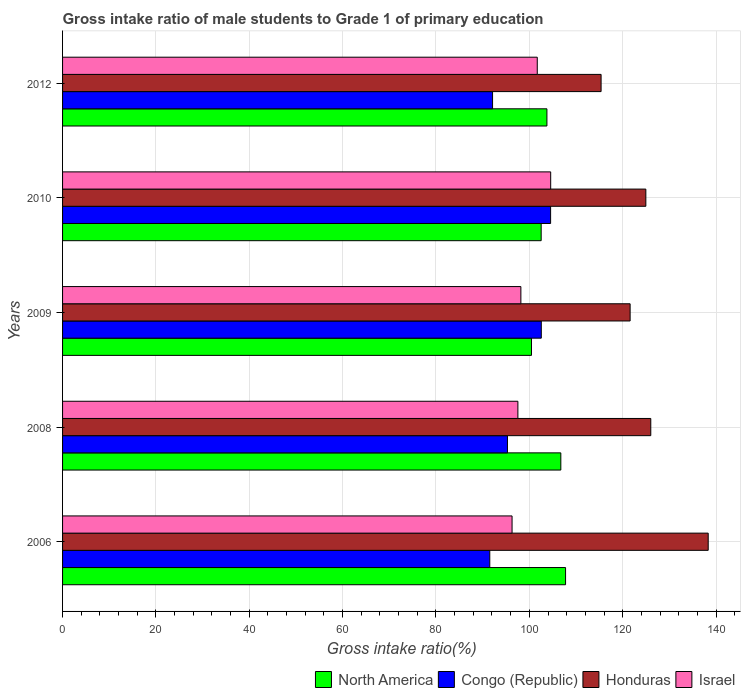Are the number of bars on each tick of the Y-axis equal?
Your answer should be very brief. Yes. How many bars are there on the 1st tick from the top?
Your answer should be compact. 4. How many bars are there on the 1st tick from the bottom?
Offer a very short reply. 4. In how many cases, is the number of bars for a given year not equal to the number of legend labels?
Offer a very short reply. 0. What is the gross intake ratio in North America in 2010?
Provide a short and direct response. 102.54. Across all years, what is the maximum gross intake ratio in North America?
Your answer should be compact. 107.76. Across all years, what is the minimum gross intake ratio in North America?
Provide a succinct answer. 100.46. In which year was the gross intake ratio in North America maximum?
Provide a succinct answer. 2006. What is the total gross intake ratio in Congo (Republic) in the graph?
Provide a succinct answer. 486.09. What is the difference between the gross intake ratio in Israel in 2008 and that in 2009?
Give a very brief answer. -0.64. What is the difference between the gross intake ratio in Congo (Republic) in 2009 and the gross intake ratio in Israel in 2012?
Ensure brevity in your answer.  0.86. What is the average gross intake ratio in Honduras per year?
Your response must be concise. 125.25. In the year 2010, what is the difference between the gross intake ratio in North America and gross intake ratio in Honduras?
Provide a short and direct response. -22.42. What is the ratio of the gross intake ratio in Israel in 2006 to that in 2010?
Give a very brief answer. 0.92. Is the gross intake ratio in Israel in 2006 less than that in 2009?
Provide a short and direct response. Yes. Is the difference between the gross intake ratio in North America in 2008 and 2012 greater than the difference between the gross intake ratio in Honduras in 2008 and 2012?
Your response must be concise. No. What is the difference between the highest and the second highest gross intake ratio in North America?
Make the answer very short. 1.01. What is the difference between the highest and the lowest gross intake ratio in Honduras?
Provide a succinct answer. 22.95. Is it the case that in every year, the sum of the gross intake ratio in Israel and gross intake ratio in Honduras is greater than the sum of gross intake ratio in North America and gross intake ratio in Congo (Republic)?
Offer a terse response. No. What does the 4th bar from the top in 2006 represents?
Give a very brief answer. North America. What does the 2nd bar from the bottom in 2010 represents?
Ensure brevity in your answer.  Congo (Republic). Is it the case that in every year, the sum of the gross intake ratio in Congo (Republic) and gross intake ratio in Israel is greater than the gross intake ratio in North America?
Provide a short and direct response. Yes. How many bars are there?
Keep it short and to the point. 20. Are all the bars in the graph horizontal?
Provide a short and direct response. Yes. How many years are there in the graph?
Your answer should be very brief. 5. Are the values on the major ticks of X-axis written in scientific E-notation?
Offer a terse response. No. Does the graph contain grids?
Keep it short and to the point. Yes. How are the legend labels stacked?
Offer a terse response. Horizontal. What is the title of the graph?
Give a very brief answer. Gross intake ratio of male students to Grade 1 of primary education. Does "Low income" appear as one of the legend labels in the graph?
Provide a short and direct response. No. What is the label or title of the X-axis?
Your answer should be compact. Gross intake ratio(%). What is the Gross intake ratio(%) of North America in 2006?
Give a very brief answer. 107.76. What is the Gross intake ratio(%) of Congo (Republic) in 2006?
Ensure brevity in your answer.  91.53. What is the Gross intake ratio(%) of Honduras in 2006?
Offer a terse response. 138.32. What is the Gross intake ratio(%) of Israel in 2006?
Provide a succinct answer. 96.3. What is the Gross intake ratio(%) in North America in 2008?
Give a very brief answer. 106.75. What is the Gross intake ratio(%) of Congo (Republic) in 2008?
Make the answer very short. 95.32. What is the Gross intake ratio(%) in Honduras in 2008?
Offer a very short reply. 126.02. What is the Gross intake ratio(%) in Israel in 2008?
Offer a terse response. 97.55. What is the Gross intake ratio(%) in North America in 2009?
Offer a terse response. 100.46. What is the Gross intake ratio(%) of Congo (Republic) in 2009?
Provide a short and direct response. 102.57. What is the Gross intake ratio(%) of Honduras in 2009?
Offer a very short reply. 121.59. What is the Gross intake ratio(%) of Israel in 2009?
Your answer should be compact. 98.19. What is the Gross intake ratio(%) in North America in 2010?
Offer a very short reply. 102.54. What is the Gross intake ratio(%) of Congo (Republic) in 2010?
Your response must be concise. 104.56. What is the Gross intake ratio(%) of Honduras in 2010?
Make the answer very short. 124.96. What is the Gross intake ratio(%) of Israel in 2010?
Provide a short and direct response. 104.58. What is the Gross intake ratio(%) in North America in 2012?
Your answer should be compact. 103.77. What is the Gross intake ratio(%) of Congo (Republic) in 2012?
Give a very brief answer. 92.12. What is the Gross intake ratio(%) of Honduras in 2012?
Provide a succinct answer. 115.37. What is the Gross intake ratio(%) of Israel in 2012?
Offer a terse response. 101.7. Across all years, what is the maximum Gross intake ratio(%) of North America?
Provide a short and direct response. 107.76. Across all years, what is the maximum Gross intake ratio(%) in Congo (Republic)?
Ensure brevity in your answer.  104.56. Across all years, what is the maximum Gross intake ratio(%) of Honduras?
Make the answer very short. 138.32. Across all years, what is the maximum Gross intake ratio(%) of Israel?
Your answer should be very brief. 104.58. Across all years, what is the minimum Gross intake ratio(%) in North America?
Give a very brief answer. 100.46. Across all years, what is the minimum Gross intake ratio(%) in Congo (Republic)?
Ensure brevity in your answer.  91.53. Across all years, what is the minimum Gross intake ratio(%) in Honduras?
Offer a terse response. 115.37. Across all years, what is the minimum Gross intake ratio(%) of Israel?
Offer a terse response. 96.3. What is the total Gross intake ratio(%) of North America in the graph?
Offer a terse response. 521.27. What is the total Gross intake ratio(%) of Congo (Republic) in the graph?
Provide a succinct answer. 486.09. What is the total Gross intake ratio(%) in Honduras in the graph?
Offer a terse response. 626.27. What is the total Gross intake ratio(%) in Israel in the graph?
Offer a terse response. 498.31. What is the difference between the Gross intake ratio(%) in North America in 2006 and that in 2008?
Your answer should be very brief. 1.01. What is the difference between the Gross intake ratio(%) of Congo (Republic) in 2006 and that in 2008?
Your answer should be very brief. -3.79. What is the difference between the Gross intake ratio(%) of Honduras in 2006 and that in 2008?
Keep it short and to the point. 12.31. What is the difference between the Gross intake ratio(%) of Israel in 2006 and that in 2008?
Provide a succinct answer. -1.25. What is the difference between the Gross intake ratio(%) in North America in 2006 and that in 2009?
Ensure brevity in your answer.  7.3. What is the difference between the Gross intake ratio(%) of Congo (Republic) in 2006 and that in 2009?
Offer a very short reply. -11.04. What is the difference between the Gross intake ratio(%) of Honduras in 2006 and that in 2009?
Keep it short and to the point. 16.73. What is the difference between the Gross intake ratio(%) of Israel in 2006 and that in 2009?
Your response must be concise. -1.89. What is the difference between the Gross intake ratio(%) in North America in 2006 and that in 2010?
Provide a succinct answer. 5.22. What is the difference between the Gross intake ratio(%) of Congo (Republic) in 2006 and that in 2010?
Offer a very short reply. -13.03. What is the difference between the Gross intake ratio(%) of Honduras in 2006 and that in 2010?
Make the answer very short. 13.36. What is the difference between the Gross intake ratio(%) of Israel in 2006 and that in 2010?
Provide a succinct answer. -8.27. What is the difference between the Gross intake ratio(%) of North America in 2006 and that in 2012?
Provide a succinct answer. 3.99. What is the difference between the Gross intake ratio(%) of Congo (Republic) in 2006 and that in 2012?
Offer a terse response. -0.59. What is the difference between the Gross intake ratio(%) of Honduras in 2006 and that in 2012?
Your answer should be very brief. 22.95. What is the difference between the Gross intake ratio(%) in Israel in 2006 and that in 2012?
Your response must be concise. -5.4. What is the difference between the Gross intake ratio(%) of North America in 2008 and that in 2009?
Make the answer very short. 6.29. What is the difference between the Gross intake ratio(%) of Congo (Republic) in 2008 and that in 2009?
Provide a succinct answer. -7.25. What is the difference between the Gross intake ratio(%) in Honduras in 2008 and that in 2009?
Give a very brief answer. 4.42. What is the difference between the Gross intake ratio(%) in Israel in 2008 and that in 2009?
Offer a very short reply. -0.64. What is the difference between the Gross intake ratio(%) of North America in 2008 and that in 2010?
Ensure brevity in your answer.  4.21. What is the difference between the Gross intake ratio(%) in Congo (Republic) in 2008 and that in 2010?
Your response must be concise. -9.24. What is the difference between the Gross intake ratio(%) in Honduras in 2008 and that in 2010?
Ensure brevity in your answer.  1.06. What is the difference between the Gross intake ratio(%) in Israel in 2008 and that in 2010?
Give a very brief answer. -7.03. What is the difference between the Gross intake ratio(%) in North America in 2008 and that in 2012?
Keep it short and to the point. 2.98. What is the difference between the Gross intake ratio(%) in Congo (Republic) in 2008 and that in 2012?
Ensure brevity in your answer.  3.19. What is the difference between the Gross intake ratio(%) in Honduras in 2008 and that in 2012?
Your answer should be compact. 10.64. What is the difference between the Gross intake ratio(%) of Israel in 2008 and that in 2012?
Ensure brevity in your answer.  -4.15. What is the difference between the Gross intake ratio(%) in North America in 2009 and that in 2010?
Give a very brief answer. -2.08. What is the difference between the Gross intake ratio(%) of Congo (Republic) in 2009 and that in 2010?
Give a very brief answer. -1.99. What is the difference between the Gross intake ratio(%) of Honduras in 2009 and that in 2010?
Give a very brief answer. -3.37. What is the difference between the Gross intake ratio(%) in Israel in 2009 and that in 2010?
Your answer should be very brief. -6.39. What is the difference between the Gross intake ratio(%) of North America in 2009 and that in 2012?
Make the answer very short. -3.31. What is the difference between the Gross intake ratio(%) of Congo (Republic) in 2009 and that in 2012?
Make the answer very short. 10.44. What is the difference between the Gross intake ratio(%) of Honduras in 2009 and that in 2012?
Give a very brief answer. 6.22. What is the difference between the Gross intake ratio(%) in Israel in 2009 and that in 2012?
Give a very brief answer. -3.51. What is the difference between the Gross intake ratio(%) of North America in 2010 and that in 2012?
Ensure brevity in your answer.  -1.23. What is the difference between the Gross intake ratio(%) of Congo (Republic) in 2010 and that in 2012?
Keep it short and to the point. 12.44. What is the difference between the Gross intake ratio(%) in Honduras in 2010 and that in 2012?
Provide a short and direct response. 9.59. What is the difference between the Gross intake ratio(%) of Israel in 2010 and that in 2012?
Provide a short and direct response. 2.87. What is the difference between the Gross intake ratio(%) of North America in 2006 and the Gross intake ratio(%) of Congo (Republic) in 2008?
Your answer should be compact. 12.44. What is the difference between the Gross intake ratio(%) in North America in 2006 and the Gross intake ratio(%) in Honduras in 2008?
Provide a succinct answer. -18.26. What is the difference between the Gross intake ratio(%) in North America in 2006 and the Gross intake ratio(%) in Israel in 2008?
Your response must be concise. 10.21. What is the difference between the Gross intake ratio(%) of Congo (Republic) in 2006 and the Gross intake ratio(%) of Honduras in 2008?
Give a very brief answer. -34.49. What is the difference between the Gross intake ratio(%) in Congo (Republic) in 2006 and the Gross intake ratio(%) in Israel in 2008?
Offer a terse response. -6.02. What is the difference between the Gross intake ratio(%) of Honduras in 2006 and the Gross intake ratio(%) of Israel in 2008?
Your answer should be very brief. 40.78. What is the difference between the Gross intake ratio(%) of North America in 2006 and the Gross intake ratio(%) of Congo (Republic) in 2009?
Provide a short and direct response. 5.2. What is the difference between the Gross intake ratio(%) in North America in 2006 and the Gross intake ratio(%) in Honduras in 2009?
Offer a terse response. -13.83. What is the difference between the Gross intake ratio(%) in North America in 2006 and the Gross intake ratio(%) in Israel in 2009?
Ensure brevity in your answer.  9.57. What is the difference between the Gross intake ratio(%) in Congo (Republic) in 2006 and the Gross intake ratio(%) in Honduras in 2009?
Give a very brief answer. -30.06. What is the difference between the Gross intake ratio(%) of Congo (Republic) in 2006 and the Gross intake ratio(%) of Israel in 2009?
Offer a very short reply. -6.66. What is the difference between the Gross intake ratio(%) of Honduras in 2006 and the Gross intake ratio(%) of Israel in 2009?
Your answer should be compact. 40.14. What is the difference between the Gross intake ratio(%) of North America in 2006 and the Gross intake ratio(%) of Congo (Republic) in 2010?
Make the answer very short. 3.2. What is the difference between the Gross intake ratio(%) in North America in 2006 and the Gross intake ratio(%) in Honduras in 2010?
Your response must be concise. -17.2. What is the difference between the Gross intake ratio(%) in North America in 2006 and the Gross intake ratio(%) in Israel in 2010?
Your answer should be compact. 3.19. What is the difference between the Gross intake ratio(%) of Congo (Republic) in 2006 and the Gross intake ratio(%) of Honduras in 2010?
Keep it short and to the point. -33.43. What is the difference between the Gross intake ratio(%) of Congo (Republic) in 2006 and the Gross intake ratio(%) of Israel in 2010?
Offer a very short reply. -13.05. What is the difference between the Gross intake ratio(%) of Honduras in 2006 and the Gross intake ratio(%) of Israel in 2010?
Provide a succinct answer. 33.75. What is the difference between the Gross intake ratio(%) of North America in 2006 and the Gross intake ratio(%) of Congo (Republic) in 2012?
Offer a terse response. 15.64. What is the difference between the Gross intake ratio(%) of North America in 2006 and the Gross intake ratio(%) of Honduras in 2012?
Your answer should be very brief. -7.61. What is the difference between the Gross intake ratio(%) in North America in 2006 and the Gross intake ratio(%) in Israel in 2012?
Your response must be concise. 6.06. What is the difference between the Gross intake ratio(%) in Congo (Republic) in 2006 and the Gross intake ratio(%) in Honduras in 2012?
Your response must be concise. -23.85. What is the difference between the Gross intake ratio(%) of Congo (Republic) in 2006 and the Gross intake ratio(%) of Israel in 2012?
Offer a terse response. -10.17. What is the difference between the Gross intake ratio(%) in Honduras in 2006 and the Gross intake ratio(%) in Israel in 2012?
Keep it short and to the point. 36.62. What is the difference between the Gross intake ratio(%) of North America in 2008 and the Gross intake ratio(%) of Congo (Republic) in 2009?
Offer a terse response. 4.18. What is the difference between the Gross intake ratio(%) of North America in 2008 and the Gross intake ratio(%) of Honduras in 2009?
Give a very brief answer. -14.85. What is the difference between the Gross intake ratio(%) of North America in 2008 and the Gross intake ratio(%) of Israel in 2009?
Offer a terse response. 8.56. What is the difference between the Gross intake ratio(%) of Congo (Republic) in 2008 and the Gross intake ratio(%) of Honduras in 2009?
Your answer should be compact. -26.28. What is the difference between the Gross intake ratio(%) in Congo (Republic) in 2008 and the Gross intake ratio(%) in Israel in 2009?
Keep it short and to the point. -2.87. What is the difference between the Gross intake ratio(%) of Honduras in 2008 and the Gross intake ratio(%) of Israel in 2009?
Your answer should be compact. 27.83. What is the difference between the Gross intake ratio(%) in North America in 2008 and the Gross intake ratio(%) in Congo (Republic) in 2010?
Offer a terse response. 2.19. What is the difference between the Gross intake ratio(%) in North America in 2008 and the Gross intake ratio(%) in Honduras in 2010?
Your answer should be compact. -18.21. What is the difference between the Gross intake ratio(%) of North America in 2008 and the Gross intake ratio(%) of Israel in 2010?
Offer a very short reply. 2.17. What is the difference between the Gross intake ratio(%) in Congo (Republic) in 2008 and the Gross intake ratio(%) in Honduras in 2010?
Keep it short and to the point. -29.64. What is the difference between the Gross intake ratio(%) in Congo (Republic) in 2008 and the Gross intake ratio(%) in Israel in 2010?
Ensure brevity in your answer.  -9.26. What is the difference between the Gross intake ratio(%) in Honduras in 2008 and the Gross intake ratio(%) in Israel in 2010?
Give a very brief answer. 21.44. What is the difference between the Gross intake ratio(%) of North America in 2008 and the Gross intake ratio(%) of Congo (Republic) in 2012?
Offer a very short reply. 14.63. What is the difference between the Gross intake ratio(%) of North America in 2008 and the Gross intake ratio(%) of Honduras in 2012?
Your answer should be compact. -8.63. What is the difference between the Gross intake ratio(%) of North America in 2008 and the Gross intake ratio(%) of Israel in 2012?
Make the answer very short. 5.05. What is the difference between the Gross intake ratio(%) of Congo (Republic) in 2008 and the Gross intake ratio(%) of Honduras in 2012?
Provide a short and direct response. -20.06. What is the difference between the Gross intake ratio(%) in Congo (Republic) in 2008 and the Gross intake ratio(%) in Israel in 2012?
Ensure brevity in your answer.  -6.38. What is the difference between the Gross intake ratio(%) in Honduras in 2008 and the Gross intake ratio(%) in Israel in 2012?
Provide a succinct answer. 24.32. What is the difference between the Gross intake ratio(%) in North America in 2009 and the Gross intake ratio(%) in Congo (Republic) in 2010?
Your response must be concise. -4.1. What is the difference between the Gross intake ratio(%) of North America in 2009 and the Gross intake ratio(%) of Honduras in 2010?
Keep it short and to the point. -24.5. What is the difference between the Gross intake ratio(%) in North America in 2009 and the Gross intake ratio(%) in Israel in 2010?
Make the answer very short. -4.11. What is the difference between the Gross intake ratio(%) in Congo (Republic) in 2009 and the Gross intake ratio(%) in Honduras in 2010?
Ensure brevity in your answer.  -22.4. What is the difference between the Gross intake ratio(%) of Congo (Republic) in 2009 and the Gross intake ratio(%) of Israel in 2010?
Offer a very short reply. -2.01. What is the difference between the Gross intake ratio(%) in Honduras in 2009 and the Gross intake ratio(%) in Israel in 2010?
Provide a succinct answer. 17.02. What is the difference between the Gross intake ratio(%) of North America in 2009 and the Gross intake ratio(%) of Congo (Republic) in 2012?
Give a very brief answer. 8.34. What is the difference between the Gross intake ratio(%) in North America in 2009 and the Gross intake ratio(%) in Honduras in 2012?
Provide a succinct answer. -14.91. What is the difference between the Gross intake ratio(%) in North America in 2009 and the Gross intake ratio(%) in Israel in 2012?
Your answer should be very brief. -1.24. What is the difference between the Gross intake ratio(%) in Congo (Republic) in 2009 and the Gross intake ratio(%) in Honduras in 2012?
Keep it short and to the point. -12.81. What is the difference between the Gross intake ratio(%) of Congo (Republic) in 2009 and the Gross intake ratio(%) of Israel in 2012?
Ensure brevity in your answer.  0.86. What is the difference between the Gross intake ratio(%) of Honduras in 2009 and the Gross intake ratio(%) of Israel in 2012?
Keep it short and to the point. 19.89. What is the difference between the Gross intake ratio(%) in North America in 2010 and the Gross intake ratio(%) in Congo (Republic) in 2012?
Provide a short and direct response. 10.41. What is the difference between the Gross intake ratio(%) in North America in 2010 and the Gross intake ratio(%) in Honduras in 2012?
Ensure brevity in your answer.  -12.84. What is the difference between the Gross intake ratio(%) in North America in 2010 and the Gross intake ratio(%) in Israel in 2012?
Ensure brevity in your answer.  0.84. What is the difference between the Gross intake ratio(%) in Congo (Republic) in 2010 and the Gross intake ratio(%) in Honduras in 2012?
Provide a succinct answer. -10.81. What is the difference between the Gross intake ratio(%) of Congo (Republic) in 2010 and the Gross intake ratio(%) of Israel in 2012?
Your response must be concise. 2.86. What is the difference between the Gross intake ratio(%) of Honduras in 2010 and the Gross intake ratio(%) of Israel in 2012?
Provide a succinct answer. 23.26. What is the average Gross intake ratio(%) of North America per year?
Make the answer very short. 104.25. What is the average Gross intake ratio(%) of Congo (Republic) per year?
Your answer should be very brief. 97.22. What is the average Gross intake ratio(%) of Honduras per year?
Ensure brevity in your answer.  125.25. What is the average Gross intake ratio(%) of Israel per year?
Give a very brief answer. 99.66. In the year 2006, what is the difference between the Gross intake ratio(%) of North America and Gross intake ratio(%) of Congo (Republic)?
Your answer should be very brief. 16.23. In the year 2006, what is the difference between the Gross intake ratio(%) of North America and Gross intake ratio(%) of Honduras?
Keep it short and to the point. -30.56. In the year 2006, what is the difference between the Gross intake ratio(%) of North America and Gross intake ratio(%) of Israel?
Your answer should be compact. 11.46. In the year 2006, what is the difference between the Gross intake ratio(%) in Congo (Republic) and Gross intake ratio(%) in Honduras?
Offer a very short reply. -46.79. In the year 2006, what is the difference between the Gross intake ratio(%) of Congo (Republic) and Gross intake ratio(%) of Israel?
Your answer should be compact. -4.77. In the year 2006, what is the difference between the Gross intake ratio(%) of Honduras and Gross intake ratio(%) of Israel?
Your response must be concise. 42.02. In the year 2008, what is the difference between the Gross intake ratio(%) of North America and Gross intake ratio(%) of Congo (Republic)?
Ensure brevity in your answer.  11.43. In the year 2008, what is the difference between the Gross intake ratio(%) of North America and Gross intake ratio(%) of Honduras?
Make the answer very short. -19.27. In the year 2008, what is the difference between the Gross intake ratio(%) of North America and Gross intake ratio(%) of Israel?
Make the answer very short. 9.2. In the year 2008, what is the difference between the Gross intake ratio(%) of Congo (Republic) and Gross intake ratio(%) of Honduras?
Your response must be concise. -30.7. In the year 2008, what is the difference between the Gross intake ratio(%) in Congo (Republic) and Gross intake ratio(%) in Israel?
Give a very brief answer. -2.23. In the year 2008, what is the difference between the Gross intake ratio(%) of Honduras and Gross intake ratio(%) of Israel?
Make the answer very short. 28.47. In the year 2009, what is the difference between the Gross intake ratio(%) of North America and Gross intake ratio(%) of Congo (Republic)?
Keep it short and to the point. -2.1. In the year 2009, what is the difference between the Gross intake ratio(%) in North America and Gross intake ratio(%) in Honduras?
Your answer should be very brief. -21.13. In the year 2009, what is the difference between the Gross intake ratio(%) in North America and Gross intake ratio(%) in Israel?
Offer a very short reply. 2.27. In the year 2009, what is the difference between the Gross intake ratio(%) in Congo (Republic) and Gross intake ratio(%) in Honduras?
Make the answer very short. -19.03. In the year 2009, what is the difference between the Gross intake ratio(%) of Congo (Republic) and Gross intake ratio(%) of Israel?
Your answer should be very brief. 4.38. In the year 2009, what is the difference between the Gross intake ratio(%) of Honduras and Gross intake ratio(%) of Israel?
Your response must be concise. 23.41. In the year 2010, what is the difference between the Gross intake ratio(%) of North America and Gross intake ratio(%) of Congo (Republic)?
Keep it short and to the point. -2.02. In the year 2010, what is the difference between the Gross intake ratio(%) of North America and Gross intake ratio(%) of Honduras?
Offer a very short reply. -22.42. In the year 2010, what is the difference between the Gross intake ratio(%) of North America and Gross intake ratio(%) of Israel?
Your answer should be very brief. -2.04. In the year 2010, what is the difference between the Gross intake ratio(%) in Congo (Republic) and Gross intake ratio(%) in Honduras?
Give a very brief answer. -20.4. In the year 2010, what is the difference between the Gross intake ratio(%) in Congo (Republic) and Gross intake ratio(%) in Israel?
Give a very brief answer. -0.02. In the year 2010, what is the difference between the Gross intake ratio(%) of Honduras and Gross intake ratio(%) of Israel?
Your response must be concise. 20.39. In the year 2012, what is the difference between the Gross intake ratio(%) of North America and Gross intake ratio(%) of Congo (Republic)?
Your answer should be compact. 11.65. In the year 2012, what is the difference between the Gross intake ratio(%) in North America and Gross intake ratio(%) in Honduras?
Offer a terse response. -11.61. In the year 2012, what is the difference between the Gross intake ratio(%) in North America and Gross intake ratio(%) in Israel?
Your answer should be compact. 2.07. In the year 2012, what is the difference between the Gross intake ratio(%) of Congo (Republic) and Gross intake ratio(%) of Honduras?
Your response must be concise. -23.25. In the year 2012, what is the difference between the Gross intake ratio(%) in Congo (Republic) and Gross intake ratio(%) in Israel?
Make the answer very short. -9.58. In the year 2012, what is the difference between the Gross intake ratio(%) in Honduras and Gross intake ratio(%) in Israel?
Offer a very short reply. 13.67. What is the ratio of the Gross intake ratio(%) of North America in 2006 to that in 2008?
Provide a short and direct response. 1.01. What is the ratio of the Gross intake ratio(%) of Congo (Republic) in 2006 to that in 2008?
Keep it short and to the point. 0.96. What is the ratio of the Gross intake ratio(%) in Honduras in 2006 to that in 2008?
Offer a terse response. 1.1. What is the ratio of the Gross intake ratio(%) of Israel in 2006 to that in 2008?
Offer a terse response. 0.99. What is the ratio of the Gross intake ratio(%) of North America in 2006 to that in 2009?
Your answer should be compact. 1.07. What is the ratio of the Gross intake ratio(%) of Congo (Republic) in 2006 to that in 2009?
Provide a succinct answer. 0.89. What is the ratio of the Gross intake ratio(%) of Honduras in 2006 to that in 2009?
Your response must be concise. 1.14. What is the ratio of the Gross intake ratio(%) of Israel in 2006 to that in 2009?
Keep it short and to the point. 0.98. What is the ratio of the Gross intake ratio(%) of North America in 2006 to that in 2010?
Your response must be concise. 1.05. What is the ratio of the Gross intake ratio(%) in Congo (Republic) in 2006 to that in 2010?
Give a very brief answer. 0.88. What is the ratio of the Gross intake ratio(%) in Honduras in 2006 to that in 2010?
Your answer should be very brief. 1.11. What is the ratio of the Gross intake ratio(%) in Israel in 2006 to that in 2010?
Provide a short and direct response. 0.92. What is the ratio of the Gross intake ratio(%) in Congo (Republic) in 2006 to that in 2012?
Keep it short and to the point. 0.99. What is the ratio of the Gross intake ratio(%) in Honduras in 2006 to that in 2012?
Make the answer very short. 1.2. What is the ratio of the Gross intake ratio(%) of Israel in 2006 to that in 2012?
Keep it short and to the point. 0.95. What is the ratio of the Gross intake ratio(%) in North America in 2008 to that in 2009?
Give a very brief answer. 1.06. What is the ratio of the Gross intake ratio(%) of Congo (Republic) in 2008 to that in 2009?
Offer a very short reply. 0.93. What is the ratio of the Gross intake ratio(%) of Honduras in 2008 to that in 2009?
Provide a short and direct response. 1.04. What is the ratio of the Gross intake ratio(%) in North America in 2008 to that in 2010?
Make the answer very short. 1.04. What is the ratio of the Gross intake ratio(%) of Congo (Republic) in 2008 to that in 2010?
Provide a succinct answer. 0.91. What is the ratio of the Gross intake ratio(%) in Honduras in 2008 to that in 2010?
Provide a succinct answer. 1.01. What is the ratio of the Gross intake ratio(%) of Israel in 2008 to that in 2010?
Your answer should be very brief. 0.93. What is the ratio of the Gross intake ratio(%) in North America in 2008 to that in 2012?
Provide a short and direct response. 1.03. What is the ratio of the Gross intake ratio(%) in Congo (Republic) in 2008 to that in 2012?
Make the answer very short. 1.03. What is the ratio of the Gross intake ratio(%) in Honduras in 2008 to that in 2012?
Provide a succinct answer. 1.09. What is the ratio of the Gross intake ratio(%) of Israel in 2008 to that in 2012?
Your response must be concise. 0.96. What is the ratio of the Gross intake ratio(%) in North America in 2009 to that in 2010?
Provide a short and direct response. 0.98. What is the ratio of the Gross intake ratio(%) of Congo (Republic) in 2009 to that in 2010?
Your response must be concise. 0.98. What is the ratio of the Gross intake ratio(%) in Honduras in 2009 to that in 2010?
Your response must be concise. 0.97. What is the ratio of the Gross intake ratio(%) of Israel in 2009 to that in 2010?
Make the answer very short. 0.94. What is the ratio of the Gross intake ratio(%) of North America in 2009 to that in 2012?
Make the answer very short. 0.97. What is the ratio of the Gross intake ratio(%) in Congo (Republic) in 2009 to that in 2012?
Your answer should be very brief. 1.11. What is the ratio of the Gross intake ratio(%) in Honduras in 2009 to that in 2012?
Your answer should be compact. 1.05. What is the ratio of the Gross intake ratio(%) in Israel in 2009 to that in 2012?
Your answer should be very brief. 0.97. What is the ratio of the Gross intake ratio(%) of North America in 2010 to that in 2012?
Offer a terse response. 0.99. What is the ratio of the Gross intake ratio(%) of Congo (Republic) in 2010 to that in 2012?
Provide a short and direct response. 1.14. What is the ratio of the Gross intake ratio(%) of Honduras in 2010 to that in 2012?
Ensure brevity in your answer.  1.08. What is the ratio of the Gross intake ratio(%) in Israel in 2010 to that in 2012?
Make the answer very short. 1.03. What is the difference between the highest and the second highest Gross intake ratio(%) of North America?
Make the answer very short. 1.01. What is the difference between the highest and the second highest Gross intake ratio(%) in Congo (Republic)?
Provide a succinct answer. 1.99. What is the difference between the highest and the second highest Gross intake ratio(%) of Honduras?
Keep it short and to the point. 12.31. What is the difference between the highest and the second highest Gross intake ratio(%) in Israel?
Keep it short and to the point. 2.87. What is the difference between the highest and the lowest Gross intake ratio(%) of North America?
Your response must be concise. 7.3. What is the difference between the highest and the lowest Gross intake ratio(%) of Congo (Republic)?
Your response must be concise. 13.03. What is the difference between the highest and the lowest Gross intake ratio(%) of Honduras?
Offer a very short reply. 22.95. What is the difference between the highest and the lowest Gross intake ratio(%) in Israel?
Make the answer very short. 8.27. 